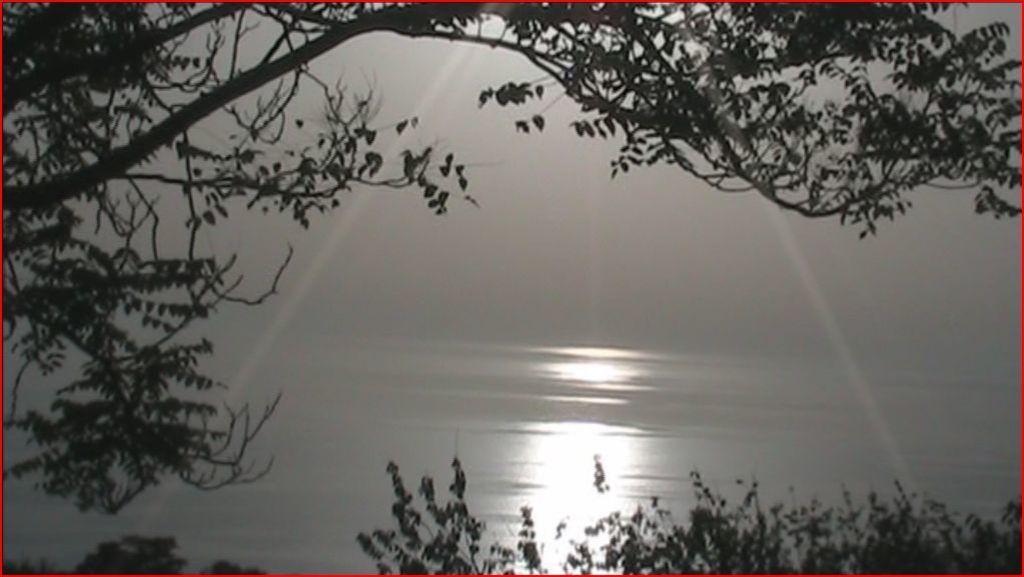In one or two sentences, can you explain what this image depicts? In this picture we can see trees, water and in the background we can see the sky. 